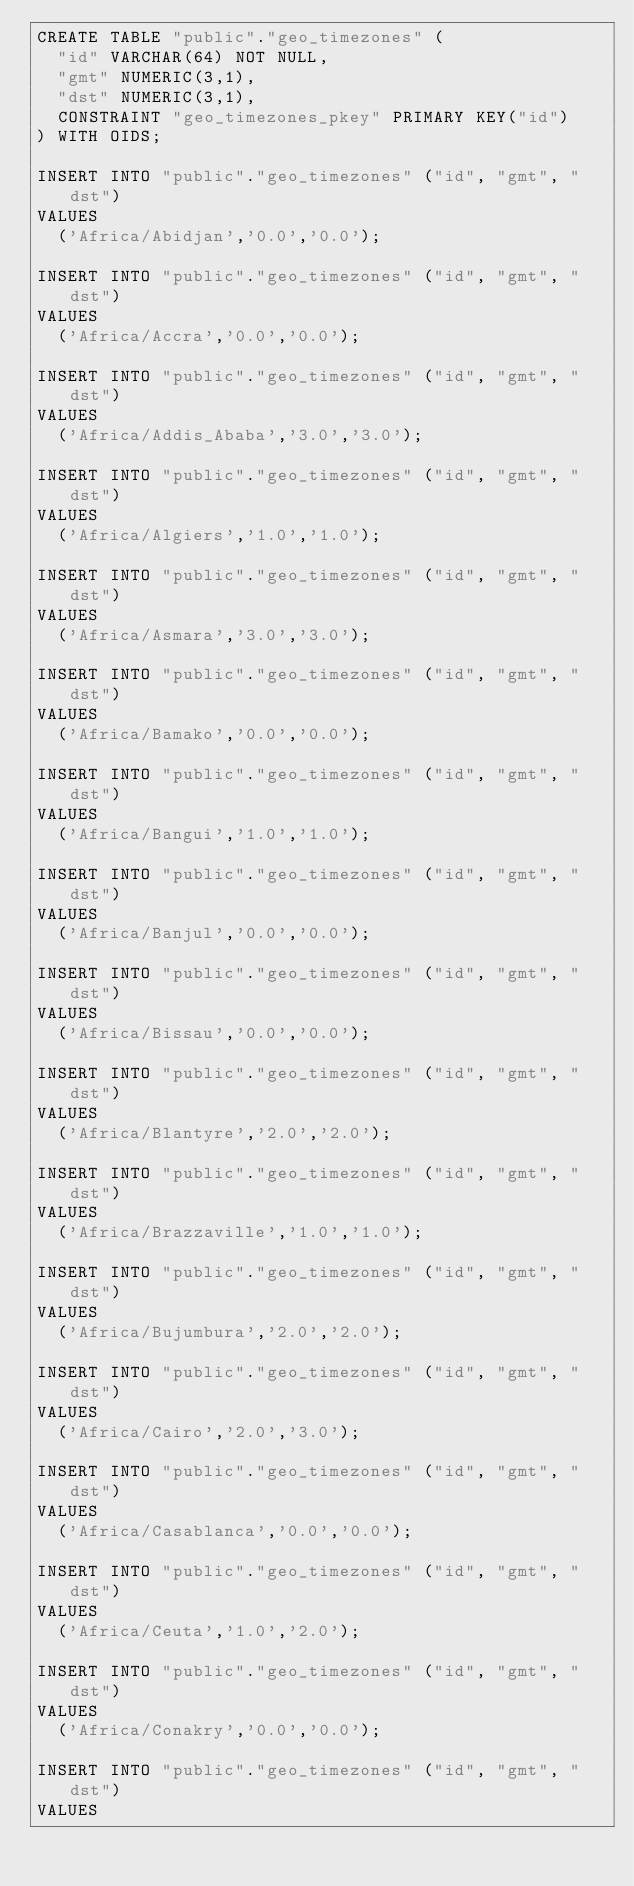<code> <loc_0><loc_0><loc_500><loc_500><_SQL_>CREATE TABLE "public"."geo_timezones" (
  "id" VARCHAR(64) NOT NULL,
  "gmt" NUMERIC(3,1),
  "dst" NUMERIC(3,1),
  CONSTRAINT "geo_timezones_pkey" PRIMARY KEY("id")
) WITH OIDS;

INSERT INTO "public"."geo_timezones" ("id", "gmt", "dst")
VALUES
  ('Africa/Abidjan','0.0','0.0');

INSERT INTO "public"."geo_timezones" ("id", "gmt", "dst")
VALUES
  ('Africa/Accra','0.0','0.0');

INSERT INTO "public"."geo_timezones" ("id", "gmt", "dst")
VALUES
  ('Africa/Addis_Ababa','3.0','3.0');

INSERT INTO "public"."geo_timezones" ("id", "gmt", "dst")
VALUES
  ('Africa/Algiers','1.0','1.0');

INSERT INTO "public"."geo_timezones" ("id", "gmt", "dst")
VALUES
  ('Africa/Asmara','3.0','3.0');

INSERT INTO "public"."geo_timezones" ("id", "gmt", "dst")
VALUES
  ('Africa/Bamako','0.0','0.0');

INSERT INTO "public"."geo_timezones" ("id", "gmt", "dst")
VALUES
  ('Africa/Bangui','1.0','1.0');

INSERT INTO "public"."geo_timezones" ("id", "gmt", "dst")
VALUES
  ('Africa/Banjul','0.0','0.0');

INSERT INTO "public"."geo_timezones" ("id", "gmt", "dst")
VALUES
  ('Africa/Bissau','0.0','0.0');

INSERT INTO "public"."geo_timezones" ("id", "gmt", "dst")
VALUES
  ('Africa/Blantyre','2.0','2.0');

INSERT INTO "public"."geo_timezones" ("id", "gmt", "dst")
VALUES
  ('Africa/Brazzaville','1.0','1.0');

INSERT INTO "public"."geo_timezones" ("id", "gmt", "dst")
VALUES
  ('Africa/Bujumbura','2.0','2.0');

INSERT INTO "public"."geo_timezones" ("id", "gmt", "dst")
VALUES
  ('Africa/Cairo','2.0','3.0');

INSERT INTO "public"."geo_timezones" ("id", "gmt", "dst")
VALUES
  ('Africa/Casablanca','0.0','0.0');

INSERT INTO "public"."geo_timezones" ("id", "gmt", "dst")
VALUES
  ('Africa/Ceuta','1.0','2.0');

INSERT INTO "public"."geo_timezones" ("id", "gmt", "dst")
VALUES
  ('Africa/Conakry','0.0','0.0');

INSERT INTO "public"."geo_timezones" ("id", "gmt", "dst")
VALUES</code> 